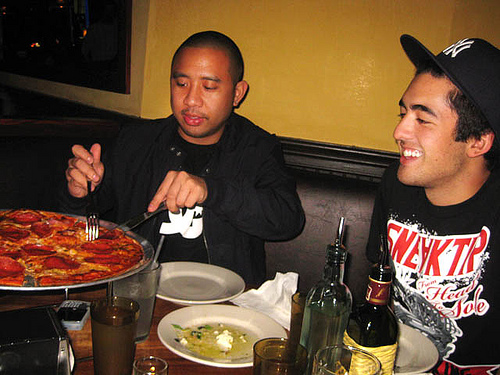Please extract the text content from this image. Head Head Sole 